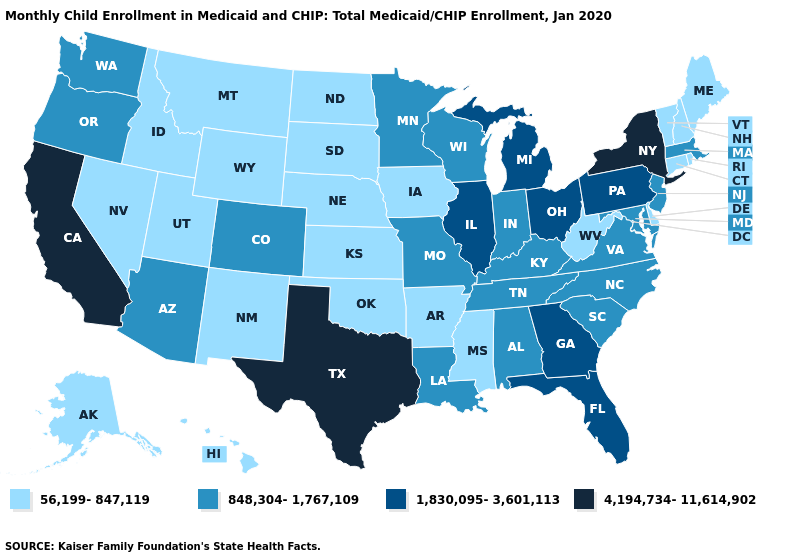Among the states that border Utah , which have the highest value?
Be succinct. Arizona, Colorado. What is the highest value in the USA?
Short answer required. 4,194,734-11,614,902. What is the value of South Dakota?
Quick response, please. 56,199-847,119. What is the value of Alabama?
Short answer required. 848,304-1,767,109. Name the states that have a value in the range 848,304-1,767,109?
Write a very short answer. Alabama, Arizona, Colorado, Indiana, Kentucky, Louisiana, Maryland, Massachusetts, Minnesota, Missouri, New Jersey, North Carolina, Oregon, South Carolina, Tennessee, Virginia, Washington, Wisconsin. Name the states that have a value in the range 848,304-1,767,109?
Quick response, please. Alabama, Arizona, Colorado, Indiana, Kentucky, Louisiana, Maryland, Massachusetts, Minnesota, Missouri, New Jersey, North Carolina, Oregon, South Carolina, Tennessee, Virginia, Washington, Wisconsin. Does Minnesota have a higher value than Arkansas?
Answer briefly. Yes. Does Wyoming have the lowest value in the West?
Short answer required. Yes. Name the states that have a value in the range 56,199-847,119?
Short answer required. Alaska, Arkansas, Connecticut, Delaware, Hawaii, Idaho, Iowa, Kansas, Maine, Mississippi, Montana, Nebraska, Nevada, New Hampshire, New Mexico, North Dakota, Oklahoma, Rhode Island, South Dakota, Utah, Vermont, West Virginia, Wyoming. Is the legend a continuous bar?
Quick response, please. No. Does the map have missing data?
Give a very brief answer. No. Name the states that have a value in the range 4,194,734-11,614,902?
Short answer required. California, New York, Texas. Is the legend a continuous bar?
Write a very short answer. No. Does Connecticut have the lowest value in the Northeast?
Short answer required. Yes. What is the lowest value in the USA?
Concise answer only. 56,199-847,119. 